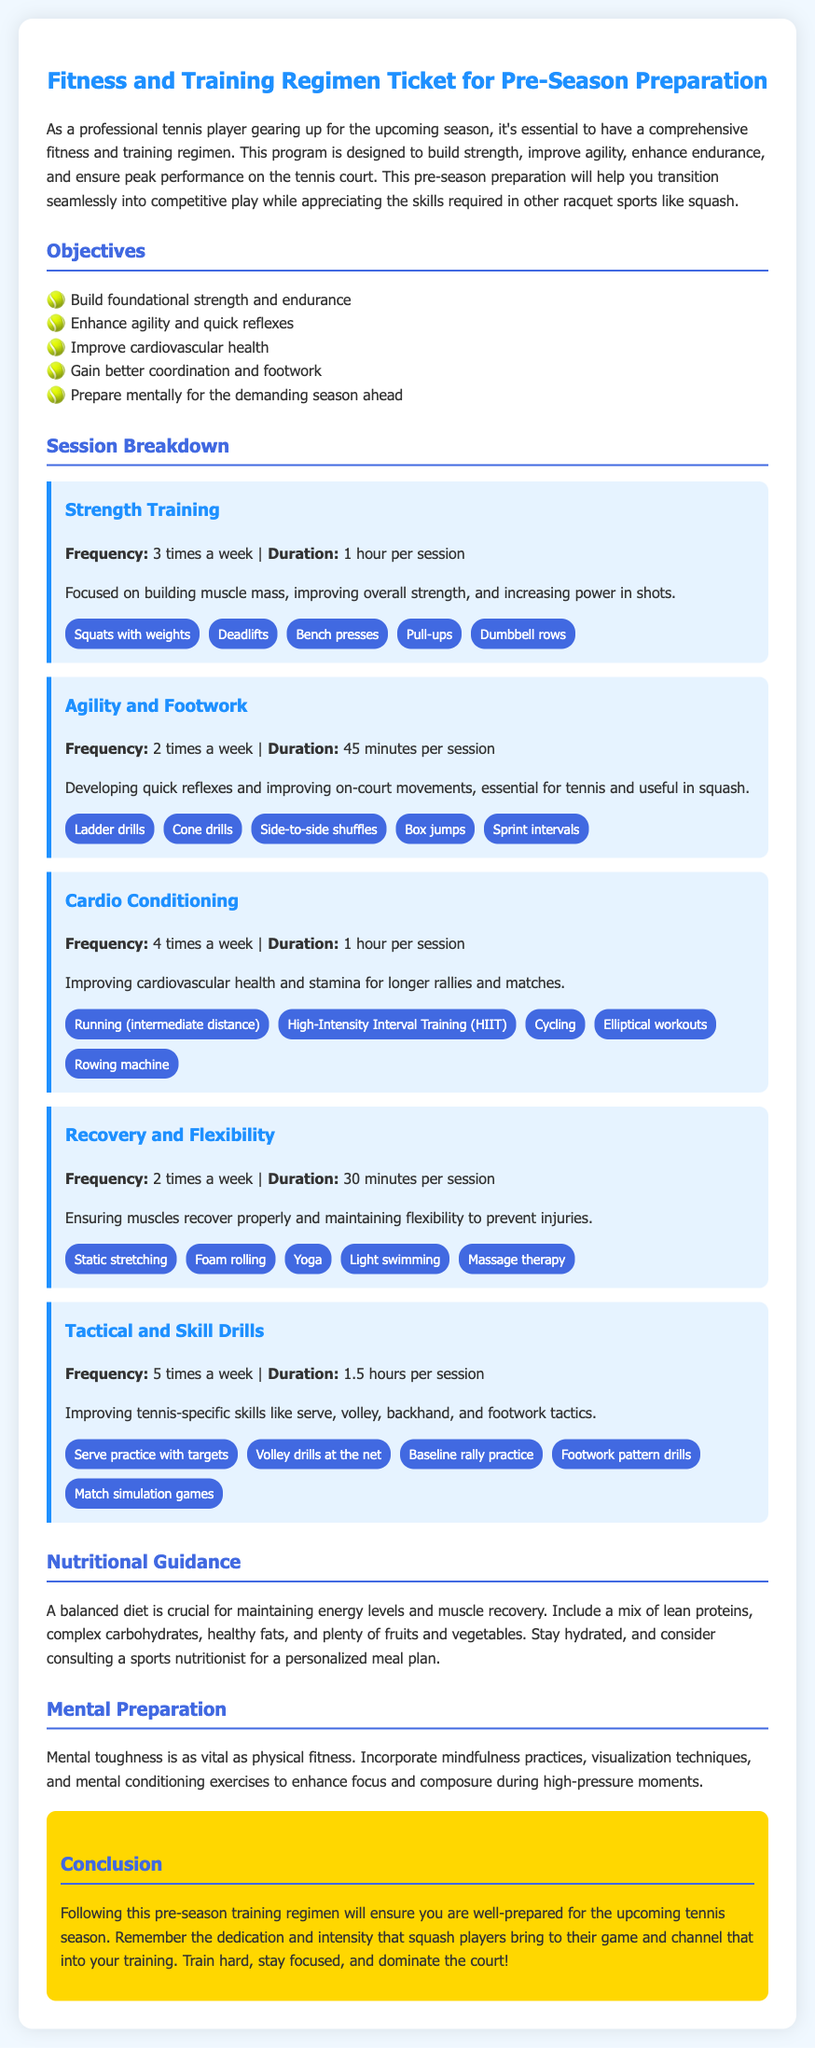What is the frequency of strength training sessions? The frequency of strength training sessions is stated in the document, which is 3 times a week.
Answer: 3 times a week What type of activities are included in agility and footwork training? The document lists specific activities included in the agility and footwork training regimen.
Answer: Ladder drills, Cone drills, Side-to-side shuffles, Box jumps, Sprint intervals How long is each cardio conditioning session? The document specifies the duration of each cardio conditioning session, which is 1 hour.
Answer: 1 hour What is the main goal of the recovery and flexibility sessions? The document highlights the primary purpose of recovery and flexibility sessions, which is to ensure muscles recover properly.
Answer: Ensure muscles recover properly How many sessions per week focus on tactical and skill drills? The number of sessions per week for tactical and skill drills is specified in the document.
Answer: 5 times a week What does the document suggest for nutritional guidance? The document provides advice on nutritional guidance to maintain energy levels, which includes a mix of certain food types.
Answer: Lean proteins, complex carbohydrates, healthy fats, fruits, vegetables What type of mental preparation is recommended in the document? The document describes specific mental preparation techniques to enhance focus and composure during games.
Answer: Mindfulness practices, visualization techniques, mental conditioning exercises How many activities are listed for strength training? The document enumerates specific activities that are part of strength training, which adds up to a total count.
Answer: 5 activities 